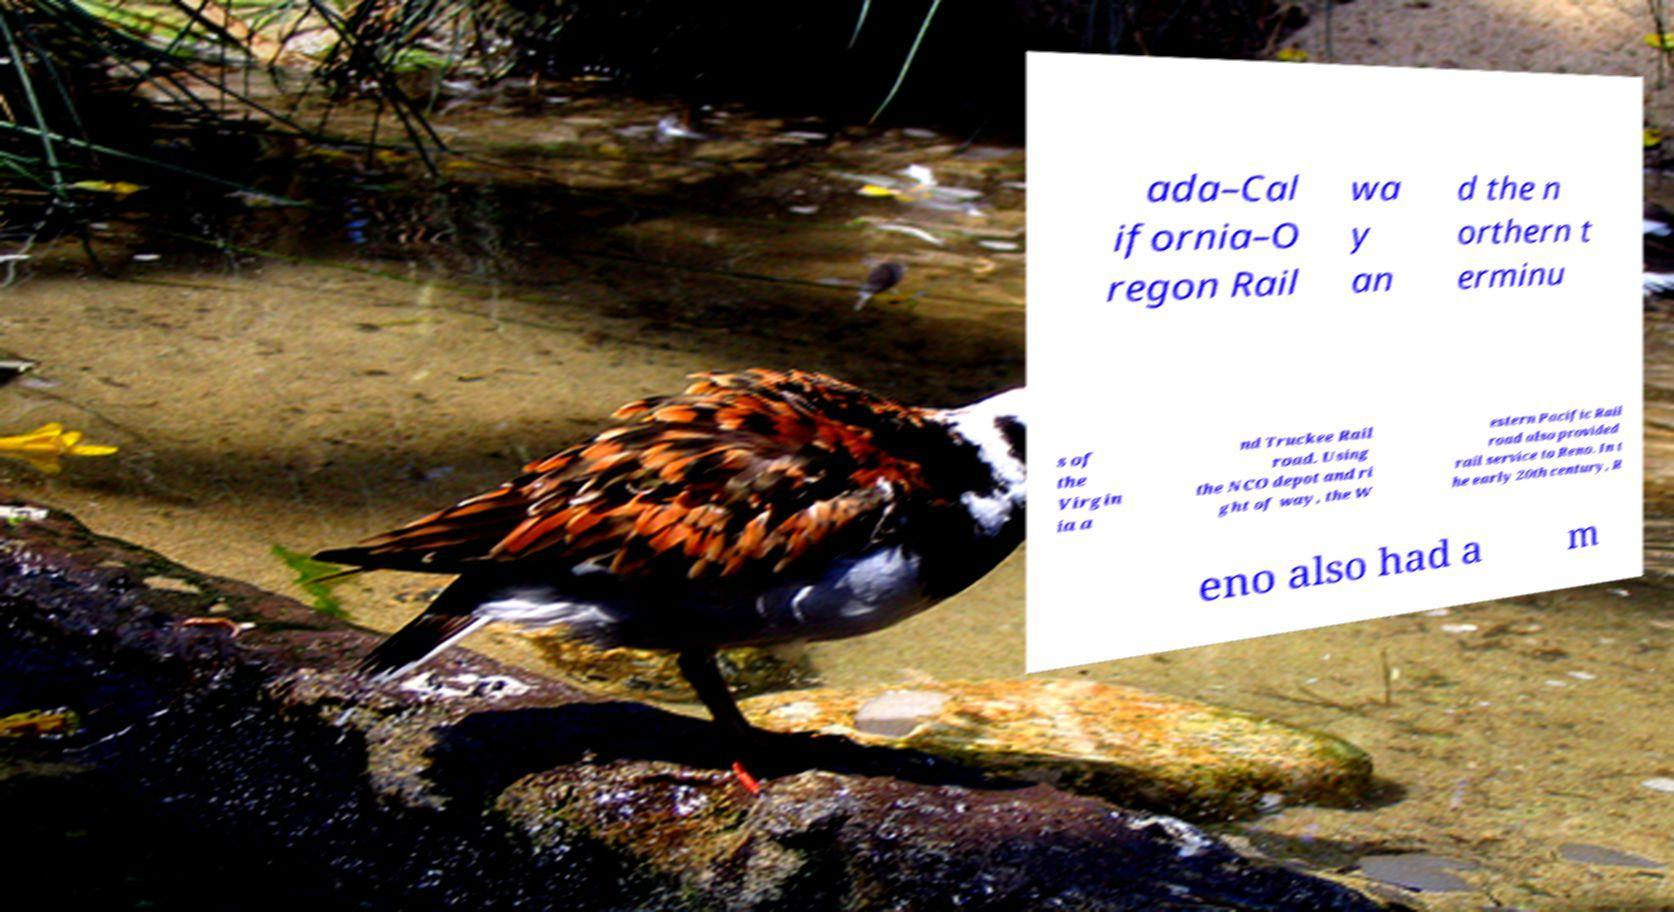I need the written content from this picture converted into text. Can you do that? ada–Cal ifornia–O regon Rail wa y an d the n orthern t erminu s of the Virgin ia a nd Truckee Rail road. Using the NCO depot and ri ght of way, the W estern Pacific Rail road also provided rail service to Reno. In t he early 20th century, R eno also had a m 